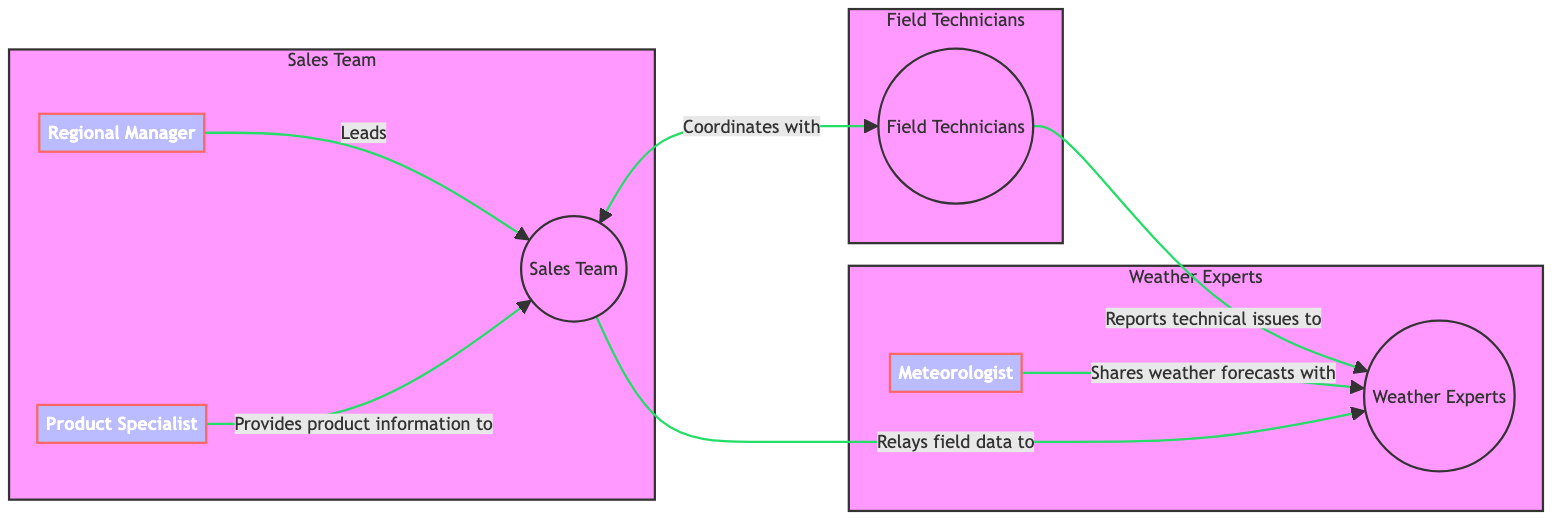What's the total number of nodes in the diagram? The diagram contains six nodes in total: Sales Team, Field Technicians, Weather Experts, Regional Manager, Product Specialist, and Meteorologist. Counting them gives us 6 nodes.
Answer: 6 Which group coordinates with the field technicians? In the diagram, the arrow labeled "Coordinates with" points from the Sales Team to the Field Technicians, indicating that the Sales Team is the one that coordinates with them.
Answer: Sales Team How many edges are connecting the nodes? The diagram has a total of five edges, as listed in the connections between the nodes: Sales Team to Field Technicians, Sales Team to Weather Experts, Field Technicians to Weather Experts, Regional Manager to Sales Team, and Product Specialist to Sales Team. Counting these edges gives us 5.
Answer: 5 Who shares weather forecasts with the weather experts? The arrow labeled "Shares weather forecasts with" leads from the Meteorologist to the Weather Experts, showing that the Meteorologist is the one sharing the forecasts.
Answer: Meteorologist Which individual provides product information to the sales team? In the diagram, the edge labeled "Provides product information to" points from the Product Specialist to the Sales Team, indicating that the Product Specialist provides this information.
Answer: Product Specialist What is the relationship between the sales team and the weather experts? The connection labeled "Relays field data to" indicates that the Sales Team relays field data to the Weather Experts, establishing a direct relationship where the Sales Team conveys information to the Weather Experts.
Answer: Relays field data to Which group does the regional manager lead? The edge labeled "Leads" points from the Regional Manager to the Sales Team, confirming that the Regional Manager leads the Sales Team.
Answer: Sales Team What do field technicians report to the weather experts? The edge labeled "Reports technical issues to" directs from Field Technicians to Weather Experts, signifying that the Field Technicians report technical issues to the Weather Experts.
Answer: Technical issues 